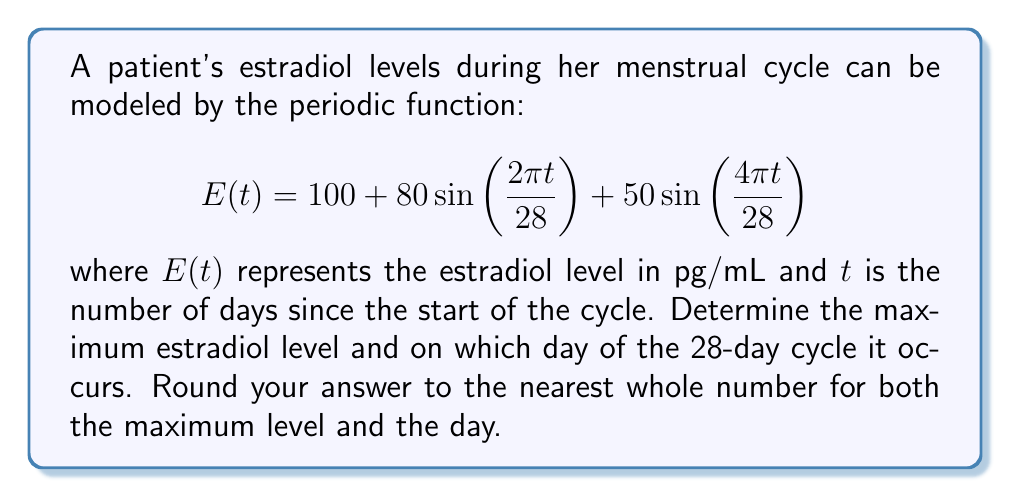Provide a solution to this math problem. To find the maximum estradiol level and when it occurs, we need to follow these steps:

1) First, we need to find the derivative of $E(t)$ and set it equal to zero to find the critical points:

   $$E'(t) = 80\cdot\frac{2\pi}{28}\cos\left(\frac{2\pi t}{28}\right) + 50\cdot\frac{4\pi}{28}\cos\left(\frac{4\pi t}{28}\right)$$

2) Setting $E'(t) = 0$:

   $$\frac{80\pi}{14}\cos\left(\frac{2\pi t}{28}\right) + \frac{100\pi}{14}\cos\left(\frac{4\pi t}{28}\right) = 0$$

3) This equation is complex to solve analytically. We can use numerical methods or graphing to find the solutions within the interval $[0, 28]$.

4) Using a graphing calculator or computer software, we find that the maximum occurs at approximately $t \approx 13.36$ days.

5) To find the maximum value, we substitute this t-value back into the original function:

   $$E(13.36) \approx 100 + 80\sin\left(\frac{2\pi \cdot 13.36}{28}\right) + 50\sin\left(\frac{4\pi \cdot 13.36}{28}\right) \approx 229.8$$

6) Rounding to the nearest whole numbers:
   - The maximum occurs on day 13 of the cycle
   - The maximum estradiol level is 230 pg/mL
Answer: 230 pg/mL on day 13 